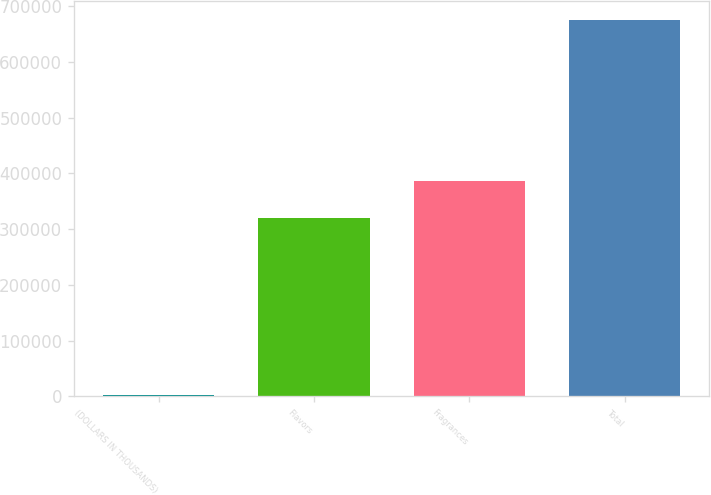Convert chart. <chart><loc_0><loc_0><loc_500><loc_500><bar_chart><fcel>(DOLLARS IN THOUSANDS)<fcel>Flavors<fcel>Fragrances<fcel>Total<nl><fcel>2014<fcel>319479<fcel>386826<fcel>675484<nl></chart> 